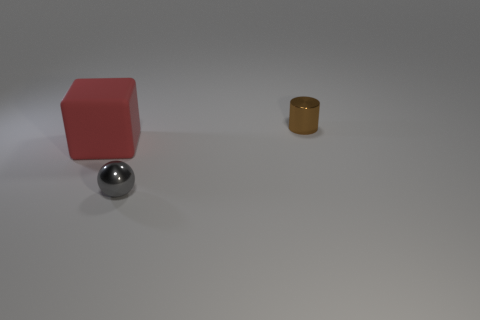What material is the tiny thing in front of the metallic thing that is behind the gray thing made of?
Your answer should be compact. Metal. Are there any large matte objects of the same shape as the tiny brown thing?
Your answer should be very brief. No. What number of other objects are the same shape as the red thing?
Give a very brief answer. 0. There is a thing that is both behind the tiny gray thing and left of the brown object; what is its shape?
Keep it short and to the point. Cube. How big is the thing to the right of the small ball?
Offer a terse response. Small. Does the metal cylinder have the same size as the gray metallic object?
Offer a terse response. Yes. Is the number of red rubber objects to the left of the tiny brown metallic cylinder less than the number of brown metal cylinders left of the big cube?
Provide a short and direct response. No. What size is the object that is behind the tiny gray metal sphere and in front of the tiny cylinder?
Give a very brief answer. Large. Is there a small metal sphere in front of the small metallic thing that is in front of the metal thing that is behind the large object?
Keep it short and to the point. No. Are any tiny metal objects visible?
Your response must be concise. Yes. 